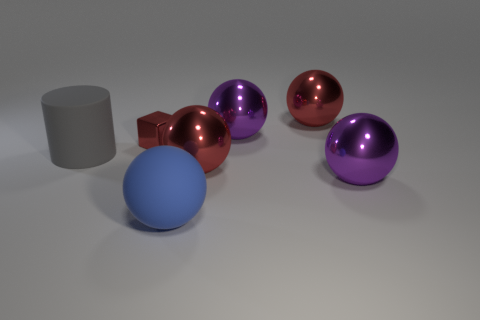What can you infer about the lighting setup in this scene? The lighting in the scene appears to be soft and diffused, which is indicated by the gentle shadows and the subtle highlights. This suggests the presence of an overhead light source, creating a neutral ambiance that does not overpower the objects in the scene. 